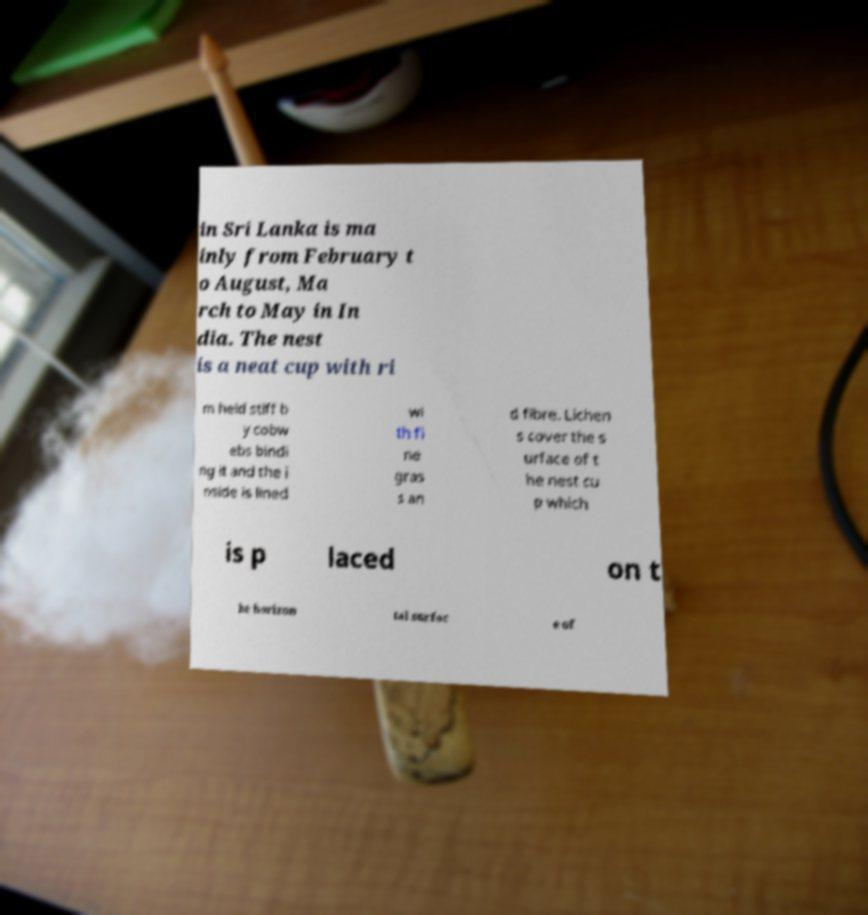Can you accurately transcribe the text from the provided image for me? in Sri Lanka is ma inly from February t o August, Ma rch to May in In dia. The nest is a neat cup with ri m held stiff b y cobw ebs bindi ng it and the i nside is lined wi th fi ne gras s an d fibre. Lichen s cover the s urface of t he nest cu p which is p laced on t he horizon tal surfac e of 